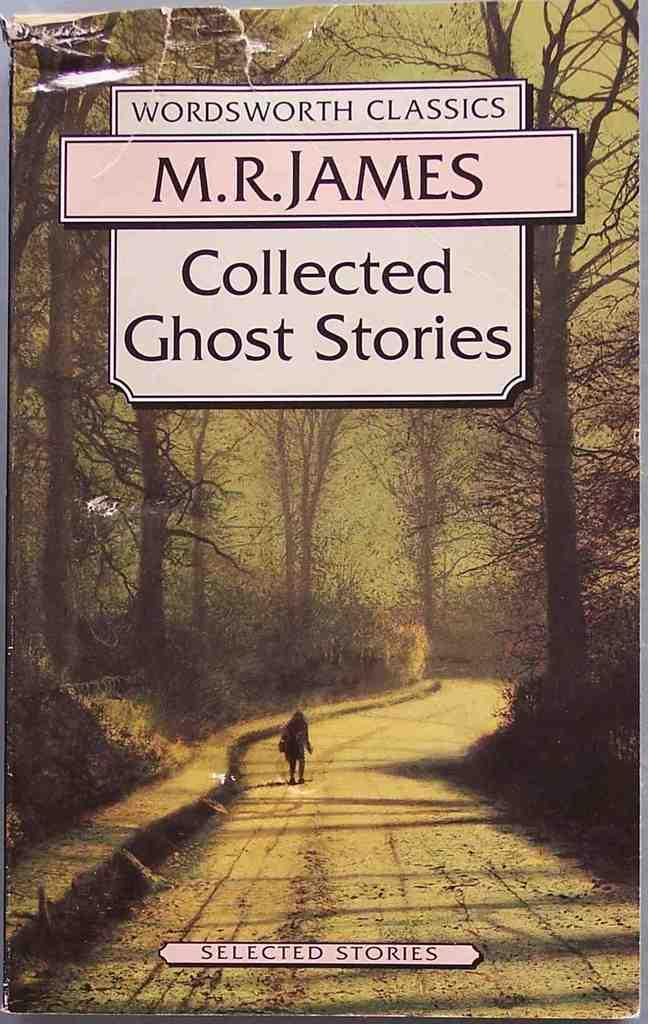<image>
Share a concise interpretation of the image provided. A book of ghost stories from Wordsworth Classics. 